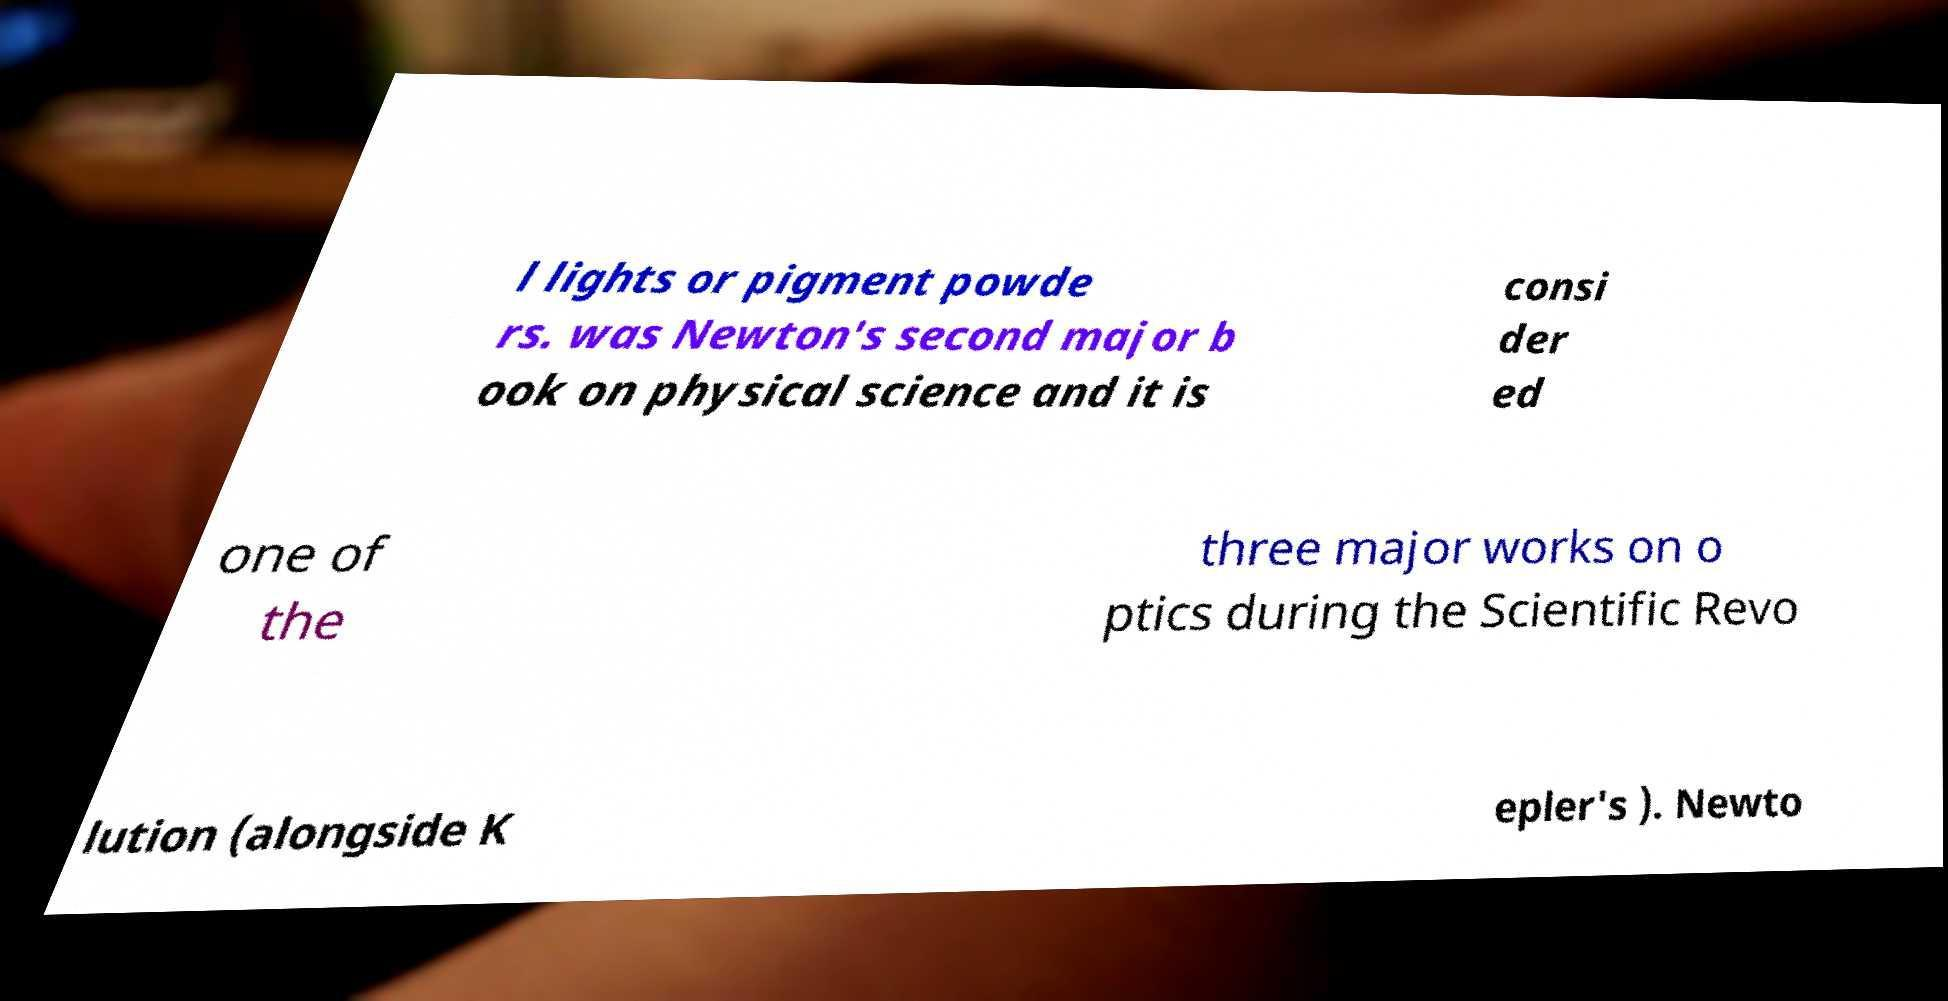What messages or text are displayed in this image? I need them in a readable, typed format. l lights or pigment powde rs. was Newton's second major b ook on physical science and it is consi der ed one of the three major works on o ptics during the Scientific Revo lution (alongside K epler's ). Newto 